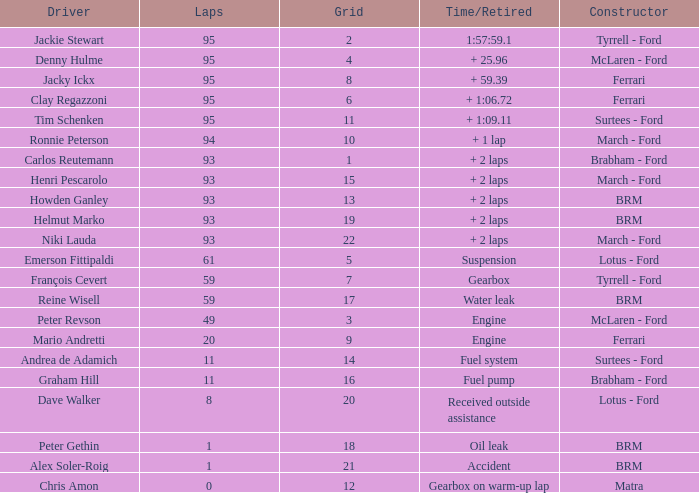How many grids does dave walker have? 1.0. 